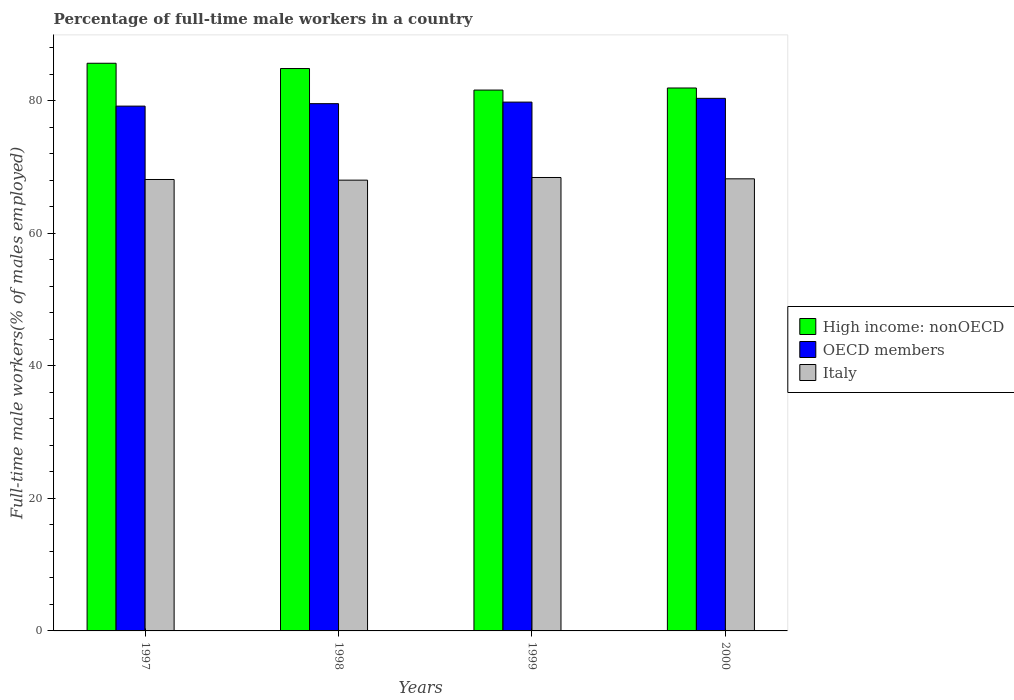How many groups of bars are there?
Your answer should be very brief. 4. Are the number of bars per tick equal to the number of legend labels?
Give a very brief answer. Yes. Are the number of bars on each tick of the X-axis equal?
Your response must be concise. Yes. How many bars are there on the 1st tick from the left?
Give a very brief answer. 3. In how many cases, is the number of bars for a given year not equal to the number of legend labels?
Your answer should be compact. 0. What is the percentage of full-time male workers in Italy in 1998?
Provide a succinct answer. 68. Across all years, what is the maximum percentage of full-time male workers in High income: nonOECD?
Offer a very short reply. 85.63. Across all years, what is the minimum percentage of full-time male workers in High income: nonOECD?
Provide a succinct answer. 81.59. What is the total percentage of full-time male workers in High income: nonOECD in the graph?
Offer a terse response. 333.96. What is the difference between the percentage of full-time male workers in OECD members in 1998 and that in 1999?
Keep it short and to the point. -0.24. What is the difference between the percentage of full-time male workers in OECD members in 2000 and the percentage of full-time male workers in Italy in 1999?
Give a very brief answer. 11.94. What is the average percentage of full-time male workers in High income: nonOECD per year?
Your answer should be very brief. 83.49. In the year 1998, what is the difference between the percentage of full-time male workers in High income: nonOECD and percentage of full-time male workers in Italy?
Your answer should be very brief. 16.84. In how many years, is the percentage of full-time male workers in Italy greater than 64 %?
Offer a terse response. 4. What is the ratio of the percentage of full-time male workers in High income: nonOECD in 1997 to that in 2000?
Your response must be concise. 1.05. Is the difference between the percentage of full-time male workers in High income: nonOECD in 1997 and 1998 greater than the difference between the percentage of full-time male workers in Italy in 1997 and 1998?
Offer a very short reply. Yes. What is the difference between the highest and the second highest percentage of full-time male workers in OECD members?
Ensure brevity in your answer.  0.57. What is the difference between the highest and the lowest percentage of full-time male workers in Italy?
Your answer should be very brief. 0.4. What does the 3rd bar from the left in 2000 represents?
Offer a terse response. Italy. What does the 3rd bar from the right in 1998 represents?
Ensure brevity in your answer.  High income: nonOECD. How many bars are there?
Keep it short and to the point. 12. Are all the bars in the graph horizontal?
Your answer should be compact. No. Does the graph contain any zero values?
Offer a very short reply. No. Where does the legend appear in the graph?
Provide a short and direct response. Center right. How many legend labels are there?
Provide a short and direct response. 3. What is the title of the graph?
Make the answer very short. Percentage of full-time male workers in a country. Does "Burkina Faso" appear as one of the legend labels in the graph?
Offer a very short reply. No. What is the label or title of the Y-axis?
Your response must be concise. Full-time male workers(% of males employed). What is the Full-time male workers(% of males employed) of High income: nonOECD in 1997?
Your response must be concise. 85.63. What is the Full-time male workers(% of males employed) in OECD members in 1997?
Keep it short and to the point. 79.17. What is the Full-time male workers(% of males employed) in Italy in 1997?
Offer a very short reply. 68.1. What is the Full-time male workers(% of males employed) in High income: nonOECD in 1998?
Keep it short and to the point. 84.84. What is the Full-time male workers(% of males employed) of OECD members in 1998?
Offer a very short reply. 79.54. What is the Full-time male workers(% of males employed) of Italy in 1998?
Your answer should be compact. 68. What is the Full-time male workers(% of males employed) of High income: nonOECD in 1999?
Give a very brief answer. 81.59. What is the Full-time male workers(% of males employed) of OECD members in 1999?
Make the answer very short. 79.77. What is the Full-time male workers(% of males employed) of Italy in 1999?
Keep it short and to the point. 68.4. What is the Full-time male workers(% of males employed) of High income: nonOECD in 2000?
Offer a very short reply. 81.9. What is the Full-time male workers(% of males employed) in OECD members in 2000?
Give a very brief answer. 80.34. What is the Full-time male workers(% of males employed) in Italy in 2000?
Give a very brief answer. 68.2. Across all years, what is the maximum Full-time male workers(% of males employed) in High income: nonOECD?
Offer a terse response. 85.63. Across all years, what is the maximum Full-time male workers(% of males employed) of OECD members?
Your response must be concise. 80.34. Across all years, what is the maximum Full-time male workers(% of males employed) of Italy?
Your answer should be compact. 68.4. Across all years, what is the minimum Full-time male workers(% of males employed) of High income: nonOECD?
Your answer should be very brief. 81.59. Across all years, what is the minimum Full-time male workers(% of males employed) of OECD members?
Provide a succinct answer. 79.17. Across all years, what is the minimum Full-time male workers(% of males employed) of Italy?
Keep it short and to the point. 68. What is the total Full-time male workers(% of males employed) in High income: nonOECD in the graph?
Keep it short and to the point. 333.96. What is the total Full-time male workers(% of males employed) in OECD members in the graph?
Your answer should be very brief. 318.82. What is the total Full-time male workers(% of males employed) of Italy in the graph?
Offer a terse response. 272.7. What is the difference between the Full-time male workers(% of males employed) of High income: nonOECD in 1997 and that in 1998?
Offer a terse response. 0.8. What is the difference between the Full-time male workers(% of males employed) in OECD members in 1997 and that in 1998?
Your response must be concise. -0.37. What is the difference between the Full-time male workers(% of males employed) in High income: nonOECD in 1997 and that in 1999?
Your answer should be very brief. 4.04. What is the difference between the Full-time male workers(% of males employed) of OECD members in 1997 and that in 1999?
Your answer should be compact. -0.6. What is the difference between the Full-time male workers(% of males employed) of Italy in 1997 and that in 1999?
Provide a succinct answer. -0.3. What is the difference between the Full-time male workers(% of males employed) of High income: nonOECD in 1997 and that in 2000?
Give a very brief answer. 3.73. What is the difference between the Full-time male workers(% of males employed) of OECD members in 1997 and that in 2000?
Offer a terse response. -1.17. What is the difference between the Full-time male workers(% of males employed) in High income: nonOECD in 1998 and that in 1999?
Keep it short and to the point. 3.25. What is the difference between the Full-time male workers(% of males employed) of OECD members in 1998 and that in 1999?
Keep it short and to the point. -0.24. What is the difference between the Full-time male workers(% of males employed) of High income: nonOECD in 1998 and that in 2000?
Offer a very short reply. 2.94. What is the difference between the Full-time male workers(% of males employed) in OECD members in 1998 and that in 2000?
Provide a short and direct response. -0.8. What is the difference between the Full-time male workers(% of males employed) of High income: nonOECD in 1999 and that in 2000?
Provide a short and direct response. -0.31. What is the difference between the Full-time male workers(% of males employed) in OECD members in 1999 and that in 2000?
Provide a succinct answer. -0.57. What is the difference between the Full-time male workers(% of males employed) of High income: nonOECD in 1997 and the Full-time male workers(% of males employed) of OECD members in 1998?
Make the answer very short. 6.1. What is the difference between the Full-time male workers(% of males employed) of High income: nonOECD in 1997 and the Full-time male workers(% of males employed) of Italy in 1998?
Your answer should be compact. 17.63. What is the difference between the Full-time male workers(% of males employed) of OECD members in 1997 and the Full-time male workers(% of males employed) of Italy in 1998?
Provide a short and direct response. 11.17. What is the difference between the Full-time male workers(% of males employed) of High income: nonOECD in 1997 and the Full-time male workers(% of males employed) of OECD members in 1999?
Make the answer very short. 5.86. What is the difference between the Full-time male workers(% of males employed) in High income: nonOECD in 1997 and the Full-time male workers(% of males employed) in Italy in 1999?
Offer a terse response. 17.23. What is the difference between the Full-time male workers(% of males employed) of OECD members in 1997 and the Full-time male workers(% of males employed) of Italy in 1999?
Your answer should be very brief. 10.77. What is the difference between the Full-time male workers(% of males employed) in High income: nonOECD in 1997 and the Full-time male workers(% of males employed) in OECD members in 2000?
Offer a very short reply. 5.29. What is the difference between the Full-time male workers(% of males employed) in High income: nonOECD in 1997 and the Full-time male workers(% of males employed) in Italy in 2000?
Give a very brief answer. 17.43. What is the difference between the Full-time male workers(% of males employed) in OECD members in 1997 and the Full-time male workers(% of males employed) in Italy in 2000?
Provide a short and direct response. 10.97. What is the difference between the Full-time male workers(% of males employed) of High income: nonOECD in 1998 and the Full-time male workers(% of males employed) of OECD members in 1999?
Keep it short and to the point. 5.06. What is the difference between the Full-time male workers(% of males employed) of High income: nonOECD in 1998 and the Full-time male workers(% of males employed) of Italy in 1999?
Provide a short and direct response. 16.44. What is the difference between the Full-time male workers(% of males employed) in OECD members in 1998 and the Full-time male workers(% of males employed) in Italy in 1999?
Provide a succinct answer. 11.14. What is the difference between the Full-time male workers(% of males employed) of High income: nonOECD in 1998 and the Full-time male workers(% of males employed) of OECD members in 2000?
Your answer should be very brief. 4.5. What is the difference between the Full-time male workers(% of males employed) of High income: nonOECD in 1998 and the Full-time male workers(% of males employed) of Italy in 2000?
Give a very brief answer. 16.64. What is the difference between the Full-time male workers(% of males employed) of OECD members in 1998 and the Full-time male workers(% of males employed) of Italy in 2000?
Your answer should be very brief. 11.34. What is the difference between the Full-time male workers(% of males employed) of High income: nonOECD in 1999 and the Full-time male workers(% of males employed) of OECD members in 2000?
Your answer should be very brief. 1.25. What is the difference between the Full-time male workers(% of males employed) of High income: nonOECD in 1999 and the Full-time male workers(% of males employed) of Italy in 2000?
Offer a very short reply. 13.39. What is the difference between the Full-time male workers(% of males employed) of OECD members in 1999 and the Full-time male workers(% of males employed) of Italy in 2000?
Your answer should be compact. 11.57. What is the average Full-time male workers(% of males employed) in High income: nonOECD per year?
Ensure brevity in your answer.  83.49. What is the average Full-time male workers(% of males employed) in OECD members per year?
Offer a terse response. 79.71. What is the average Full-time male workers(% of males employed) in Italy per year?
Provide a short and direct response. 68.17. In the year 1997, what is the difference between the Full-time male workers(% of males employed) of High income: nonOECD and Full-time male workers(% of males employed) of OECD members?
Provide a short and direct response. 6.47. In the year 1997, what is the difference between the Full-time male workers(% of males employed) in High income: nonOECD and Full-time male workers(% of males employed) in Italy?
Make the answer very short. 17.53. In the year 1997, what is the difference between the Full-time male workers(% of males employed) of OECD members and Full-time male workers(% of males employed) of Italy?
Offer a terse response. 11.07. In the year 1998, what is the difference between the Full-time male workers(% of males employed) of High income: nonOECD and Full-time male workers(% of males employed) of OECD members?
Provide a short and direct response. 5.3. In the year 1998, what is the difference between the Full-time male workers(% of males employed) in High income: nonOECD and Full-time male workers(% of males employed) in Italy?
Offer a very short reply. 16.84. In the year 1998, what is the difference between the Full-time male workers(% of males employed) of OECD members and Full-time male workers(% of males employed) of Italy?
Your answer should be compact. 11.54. In the year 1999, what is the difference between the Full-time male workers(% of males employed) in High income: nonOECD and Full-time male workers(% of males employed) in OECD members?
Make the answer very short. 1.82. In the year 1999, what is the difference between the Full-time male workers(% of males employed) in High income: nonOECD and Full-time male workers(% of males employed) in Italy?
Offer a very short reply. 13.19. In the year 1999, what is the difference between the Full-time male workers(% of males employed) in OECD members and Full-time male workers(% of males employed) in Italy?
Offer a terse response. 11.37. In the year 2000, what is the difference between the Full-time male workers(% of males employed) in High income: nonOECD and Full-time male workers(% of males employed) in OECD members?
Keep it short and to the point. 1.56. In the year 2000, what is the difference between the Full-time male workers(% of males employed) in High income: nonOECD and Full-time male workers(% of males employed) in Italy?
Ensure brevity in your answer.  13.7. In the year 2000, what is the difference between the Full-time male workers(% of males employed) of OECD members and Full-time male workers(% of males employed) of Italy?
Keep it short and to the point. 12.14. What is the ratio of the Full-time male workers(% of males employed) of High income: nonOECD in 1997 to that in 1998?
Your answer should be very brief. 1.01. What is the ratio of the Full-time male workers(% of males employed) in High income: nonOECD in 1997 to that in 1999?
Keep it short and to the point. 1.05. What is the ratio of the Full-time male workers(% of males employed) of OECD members in 1997 to that in 1999?
Ensure brevity in your answer.  0.99. What is the ratio of the Full-time male workers(% of males employed) in Italy in 1997 to that in 1999?
Provide a succinct answer. 1. What is the ratio of the Full-time male workers(% of males employed) of High income: nonOECD in 1997 to that in 2000?
Make the answer very short. 1.05. What is the ratio of the Full-time male workers(% of males employed) in OECD members in 1997 to that in 2000?
Your answer should be very brief. 0.99. What is the ratio of the Full-time male workers(% of males employed) in High income: nonOECD in 1998 to that in 1999?
Your response must be concise. 1.04. What is the ratio of the Full-time male workers(% of males employed) of OECD members in 1998 to that in 1999?
Provide a succinct answer. 1. What is the ratio of the Full-time male workers(% of males employed) in High income: nonOECD in 1998 to that in 2000?
Offer a very short reply. 1.04. What is the ratio of the Full-time male workers(% of males employed) of Italy in 1998 to that in 2000?
Provide a succinct answer. 1. What is the ratio of the Full-time male workers(% of males employed) of High income: nonOECD in 1999 to that in 2000?
Your answer should be very brief. 1. What is the ratio of the Full-time male workers(% of males employed) of Italy in 1999 to that in 2000?
Provide a succinct answer. 1. What is the difference between the highest and the second highest Full-time male workers(% of males employed) of High income: nonOECD?
Your response must be concise. 0.8. What is the difference between the highest and the second highest Full-time male workers(% of males employed) in OECD members?
Provide a short and direct response. 0.57. What is the difference between the highest and the lowest Full-time male workers(% of males employed) of High income: nonOECD?
Give a very brief answer. 4.04. What is the difference between the highest and the lowest Full-time male workers(% of males employed) of OECD members?
Ensure brevity in your answer.  1.17. 